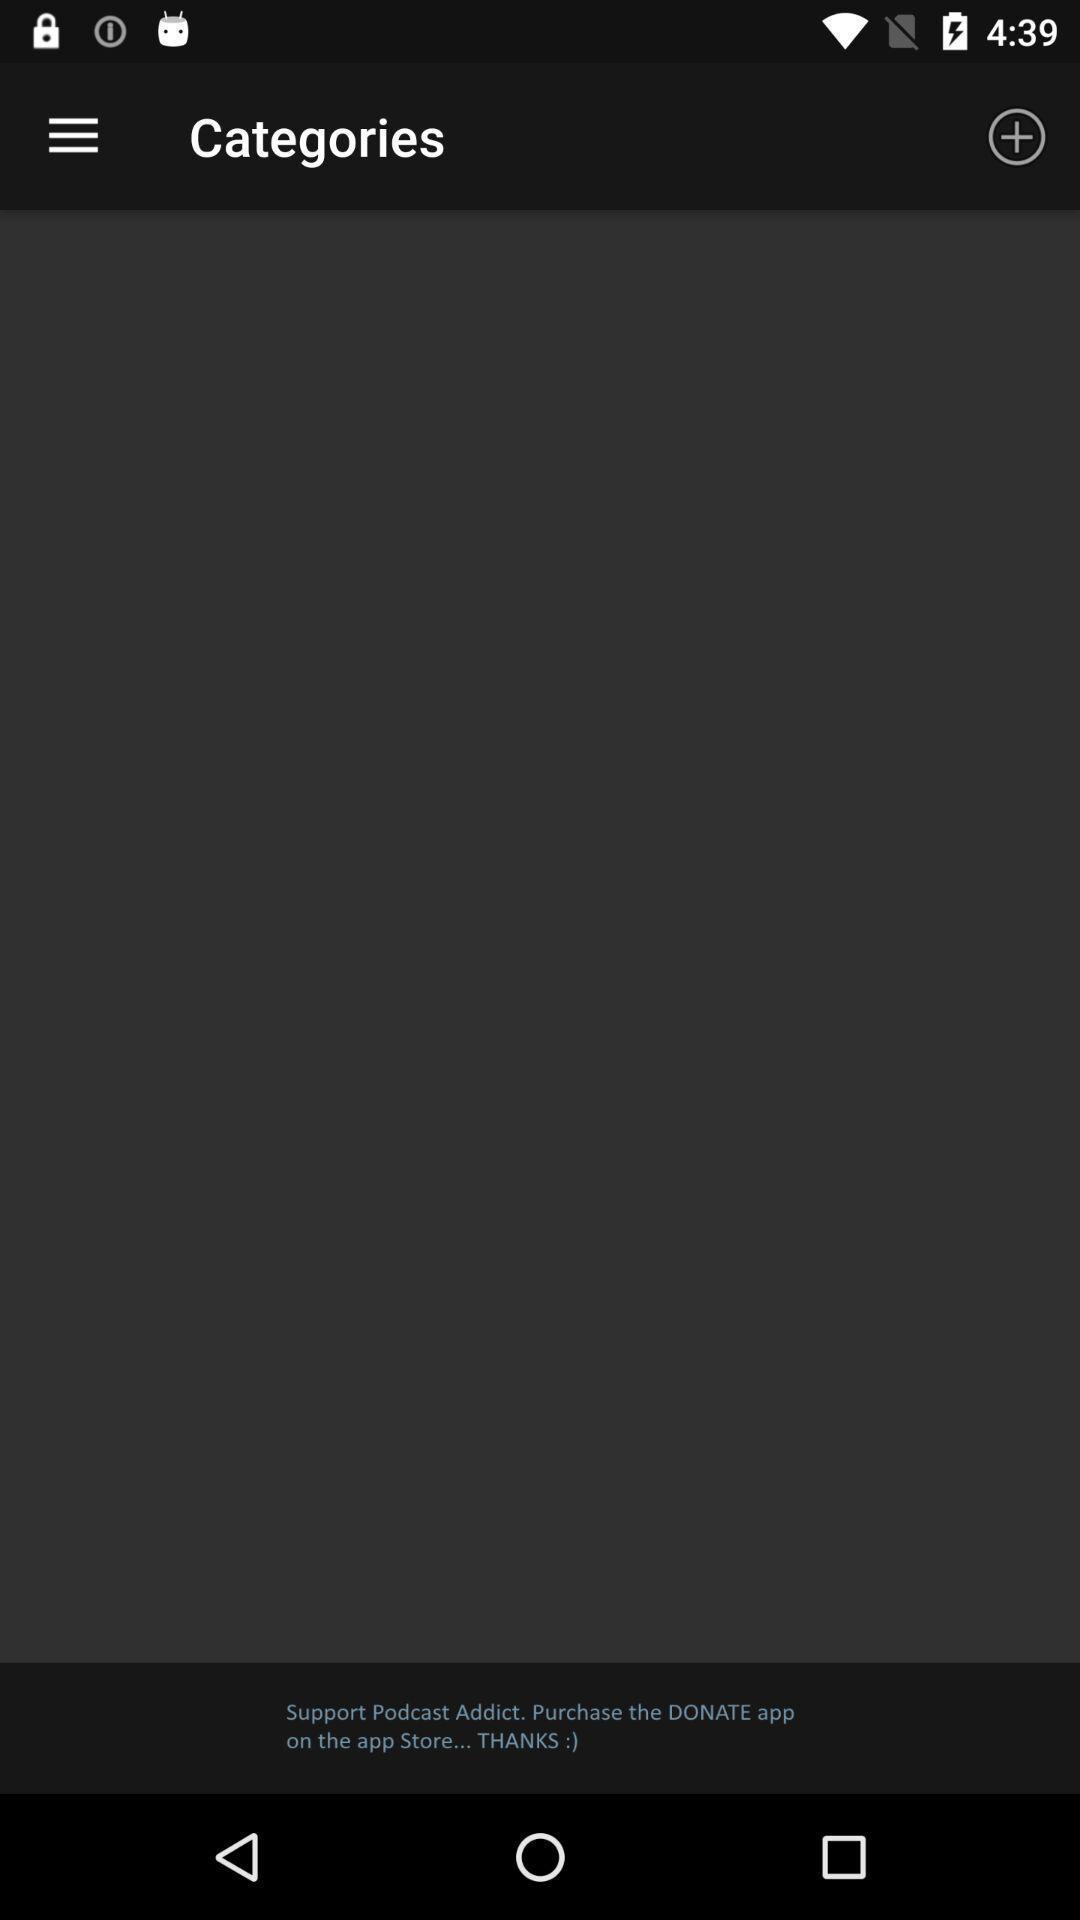Describe the key features of this screenshot. Page of categories in the app. 